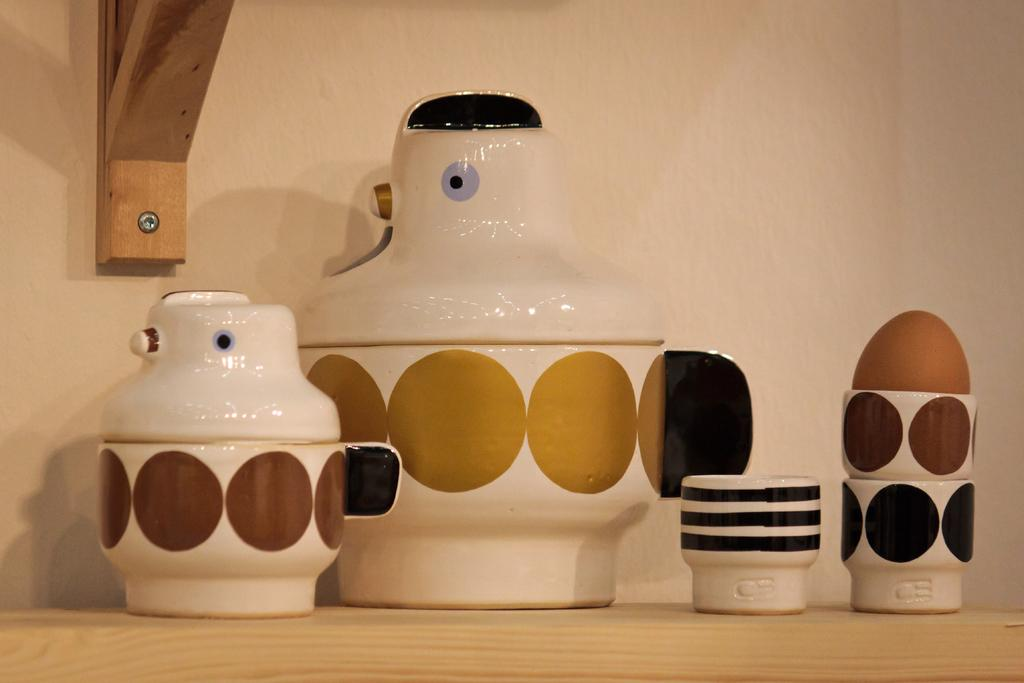What type of items can be seen in the image? There are crockery items in the image. Where are the crockery items placed? The crockery items are on a wooden plank. What can be seen behind the wooden plank? There is a wall visible in the image. How is the wooden plank attached to the wall? The wall has a wooden plank attached to it. What type of camera is used to capture the image? The type of camera used to capture the image is not mentioned in the facts provided. Is there a faucet visible in the image? There is no mention of a faucet in the facts provided, so it cannot be determined if one is present in the image. 